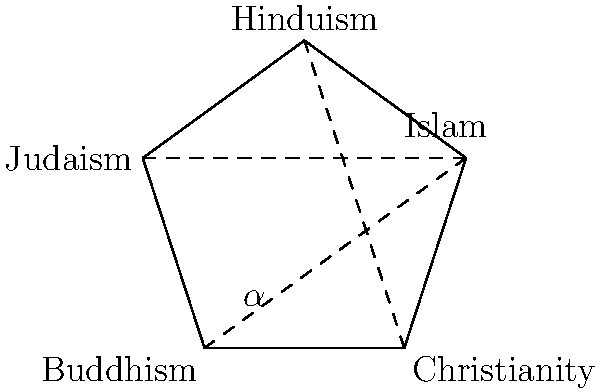In this regular pentagon representing five major world religions, each vertex symbolizes a different faith tradition. If we consider the internal angle formed at each vertex as representing the unique perspective of that religion, what is the measure of this angle ($\alpha$) in degrees? How might this angle's measure relate to the idea of unity in diversity among world religions? To find the measure of the internal angle in a regular pentagon:

1. First, recall that the sum of interior angles of any pentagon is $(5-2) \times 180^\circ = 540^\circ$.

2. In a regular pentagon, all interior angles are equal. So, we divide the total by 5:

   $\alpha = \frac{540^\circ}{5} = 108^\circ$

3. We can also derive this using the formula for regular polygons:

   $\alpha = \frac{(n-2) \times 180^\circ}{n}$, where $n$ is the number of sides.
   
   For a pentagon, $n = 5$, so:
   $\alpha = \frac{(5-2) \times 180^\circ}{5} = \frac{540^\circ}{5} = 108^\circ$

4. Relating to unity in diversity:
   - The $108^\circ$ angle is larger than a right angle ($90^\circ$), suggesting an "openness" or "embracing" quality.
   - All angles sum to $540^\circ$, a multiple of $108^\circ$, indicating how individual perspectives contribute to a greater whole.
   - The pentagon's symmetry reflects how these diverse traditions can coexist in harmony while maintaining their unique identities.

This geometric representation can serve as a metaphor for how different religious perspectives, while distinct, can form a cohesive and harmonious whole in the broader context of human spirituality and philosophical inquiry.
Answer: $108^\circ$ 